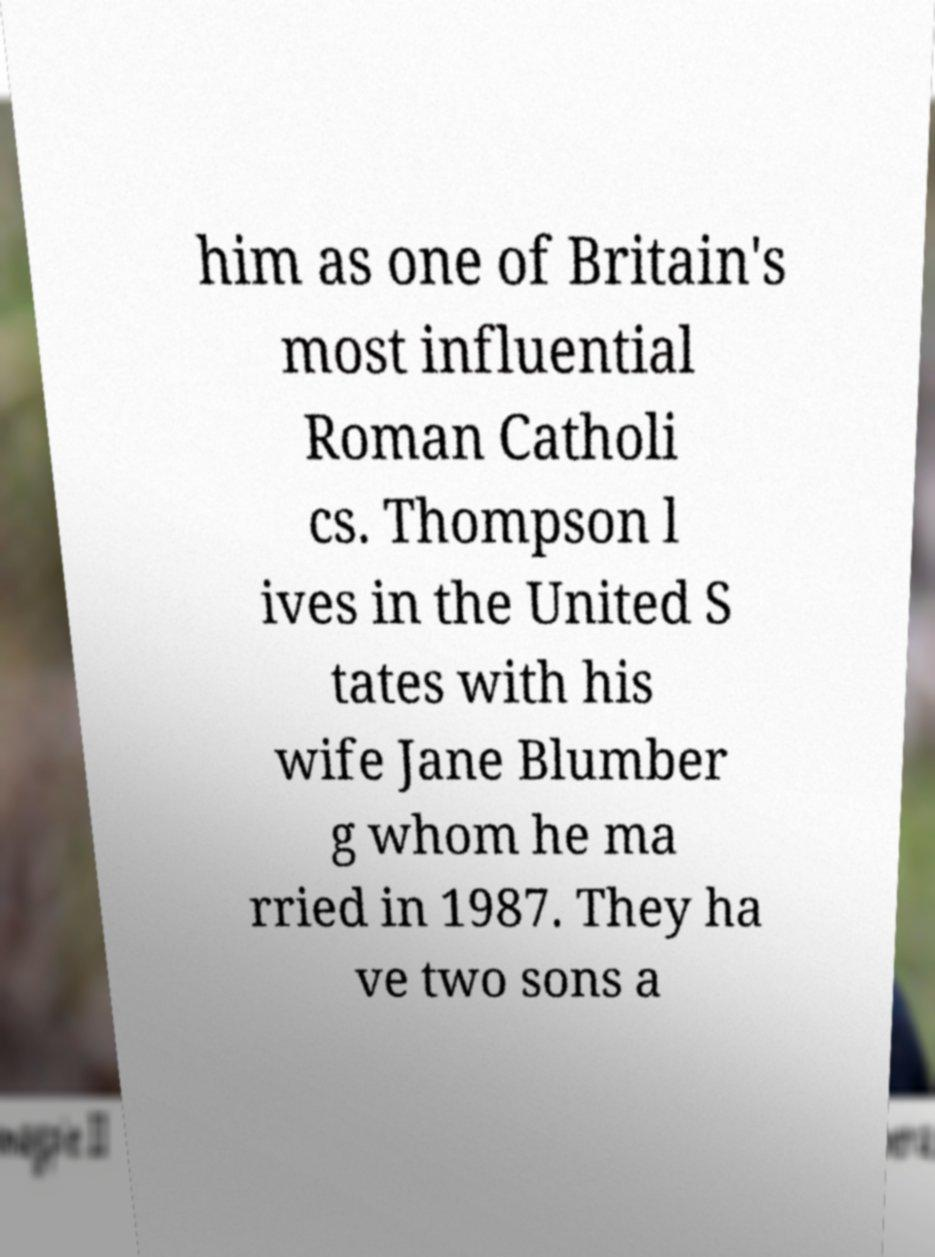What messages or text are displayed in this image? I need them in a readable, typed format. him as one of Britain's most influential Roman Catholi cs. Thompson l ives in the United S tates with his wife Jane Blumber g whom he ma rried in 1987. They ha ve two sons a 